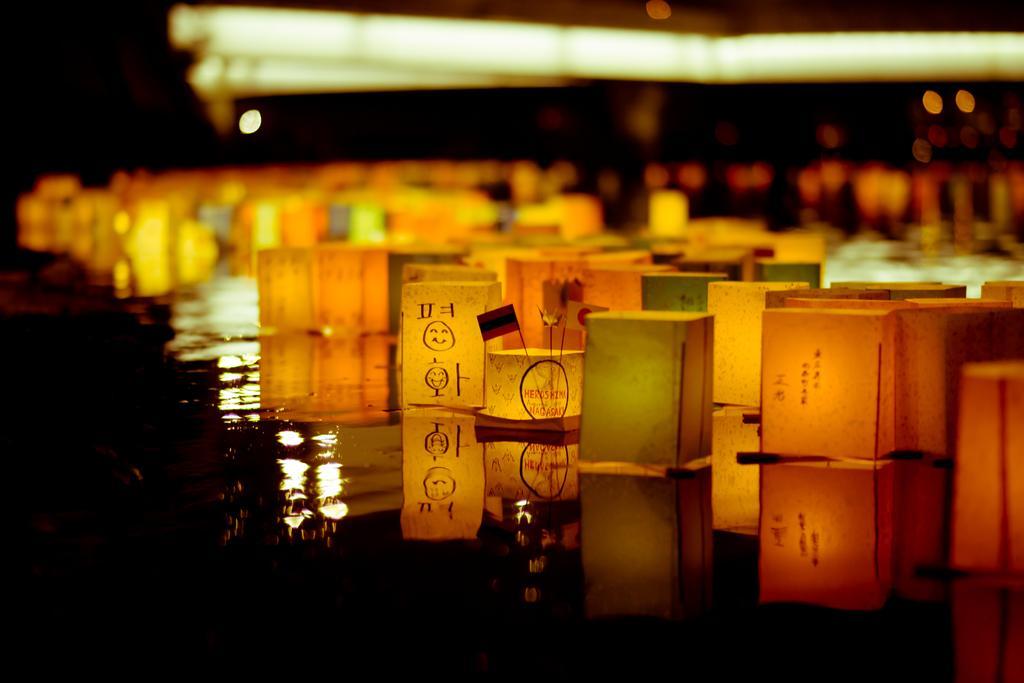Could you give a brief overview of what you see in this image? In this picture I can see few lanterns floating on the water and I can see lights on the top. 